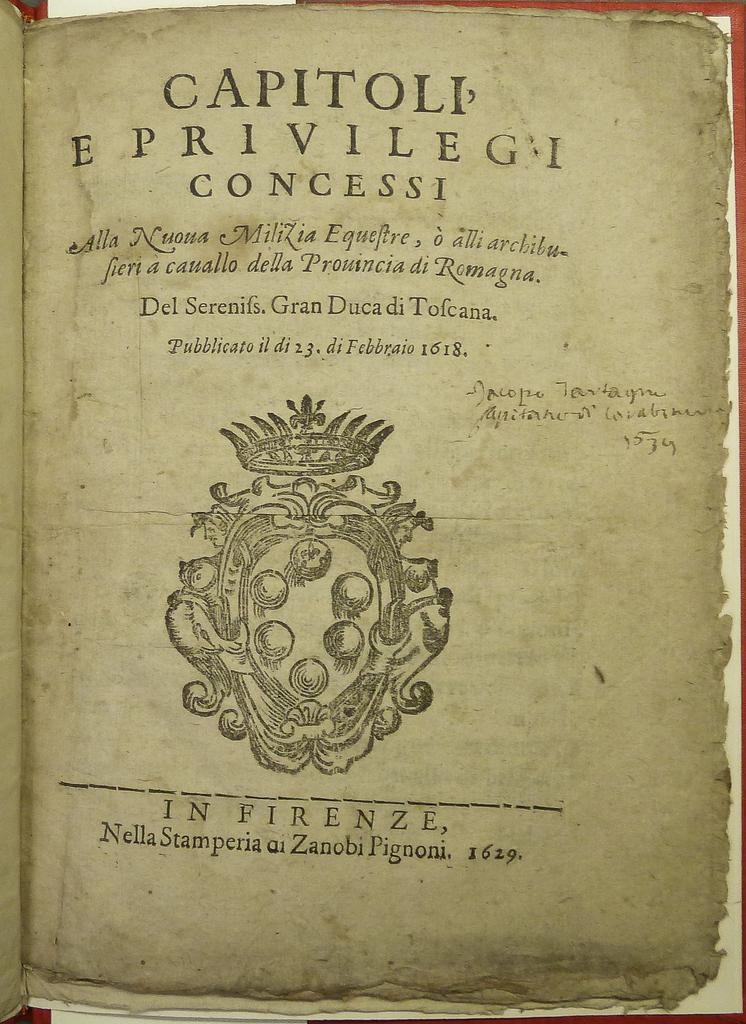<image>
Write a terse but informative summary of the picture. A very old looking book with the title CAPITOLI E PRIVILEGI CONCESSI. 